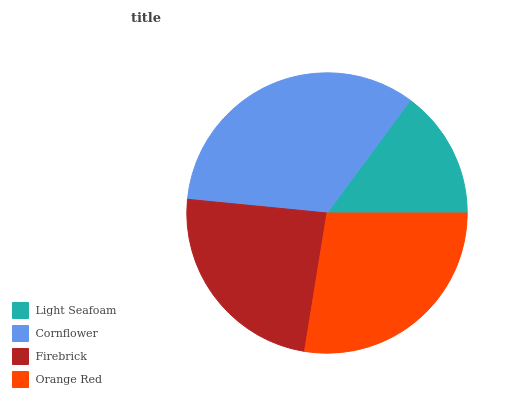Is Light Seafoam the minimum?
Answer yes or no. Yes. Is Cornflower the maximum?
Answer yes or no. Yes. Is Firebrick the minimum?
Answer yes or no. No. Is Firebrick the maximum?
Answer yes or no. No. Is Cornflower greater than Firebrick?
Answer yes or no. Yes. Is Firebrick less than Cornflower?
Answer yes or no. Yes. Is Firebrick greater than Cornflower?
Answer yes or no. No. Is Cornflower less than Firebrick?
Answer yes or no. No. Is Orange Red the high median?
Answer yes or no. Yes. Is Firebrick the low median?
Answer yes or no. Yes. Is Cornflower the high median?
Answer yes or no. No. Is Light Seafoam the low median?
Answer yes or no. No. 